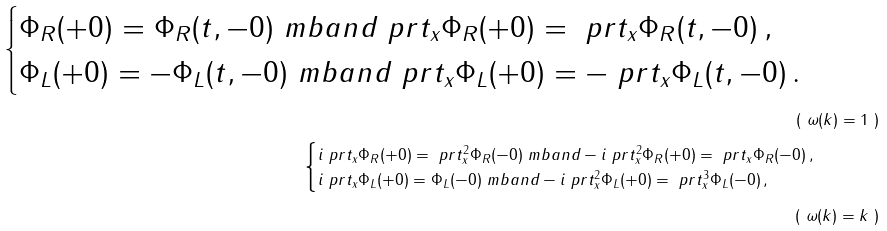<formula> <loc_0><loc_0><loc_500><loc_500>\begin{cases} \Phi _ { R } ( + 0 ) = \Phi _ { R } ( t , - 0 ) \ m b { a n d } \ p r t _ { x } \Phi _ { R } ( + 0 ) = \ p r t _ { x } \Phi _ { R } ( t , - 0 ) \, , \\ \Phi _ { L } ( + 0 ) = - \Phi _ { L } ( t , - 0 ) \ m b { a n d } \ p r t _ { x } \Phi _ { L } ( + 0 ) = - \ p r t _ { x } \Phi _ { L } ( t , - 0 ) \, . \end{cases} \tag* { ( $ \omega ( k ) = 1 $ ) } \\ \begin{cases} i \ p r t _ { x } \Phi _ { R } ( + 0 ) = \ p r t _ { x } ^ { 2 } \Phi _ { R } ( - 0 ) \ m b { a n d } - i \ p r t _ { x } ^ { 2 } \Phi _ { R } ( + 0 ) = \ p r t _ { x } \Phi _ { R } ( - 0 ) \, , \\ i \ p r t _ { x } \Phi _ { L } ( + 0 ) = \Phi _ { L } ( - 0 ) \ m b { a n d } - i \ p r t _ { x } ^ { 2 } \Phi _ { L } ( + 0 ) = \ p r t _ { x } ^ { 3 } \Phi _ { L } ( - 0 ) \, , \end{cases} \tag* { ( $ \omega ( k ) = k $ ) }</formula> 